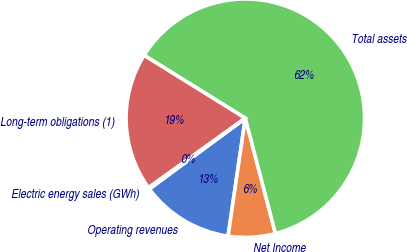Convert chart to OTSL. <chart><loc_0><loc_0><loc_500><loc_500><pie_chart><fcel>Operating revenues<fcel>Net Income<fcel>Total assets<fcel>Long-term obligations (1)<fcel>Electric energy sales (GWh)<nl><fcel>12.57%<fcel>6.38%<fcel>62.08%<fcel>18.76%<fcel>0.2%<nl></chart> 